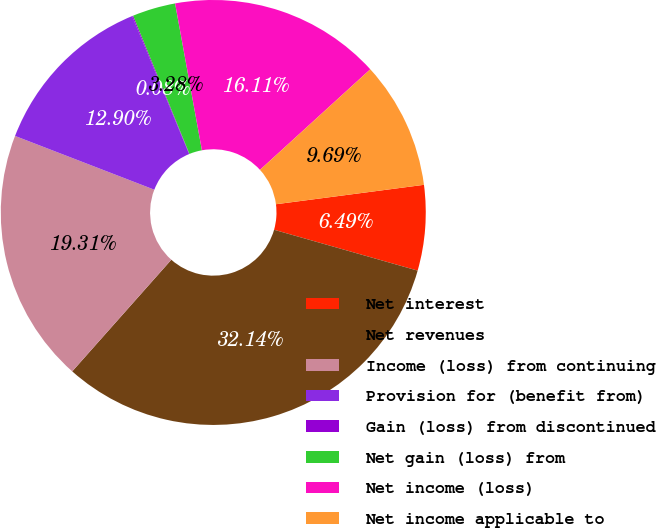Convert chart. <chart><loc_0><loc_0><loc_500><loc_500><pie_chart><fcel>Net interest<fcel>Net revenues<fcel>Income (loss) from continuing<fcel>Provision for (benefit from)<fcel>Gain (loss) from discontinued<fcel>Net gain (loss) from<fcel>Net income (loss)<fcel>Net income applicable to<nl><fcel>6.49%<fcel>32.14%<fcel>19.31%<fcel>12.9%<fcel>0.08%<fcel>3.28%<fcel>16.11%<fcel>9.69%<nl></chart> 